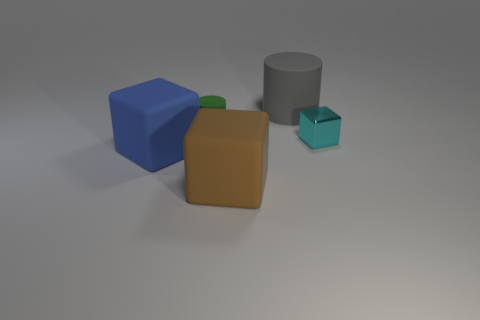What number of things are both left of the cyan shiny thing and in front of the green matte cylinder?
Make the answer very short. 2. What material is the cylinder to the left of the big gray rubber thing?
Offer a terse response. Rubber. There is a blue object that is made of the same material as the large cylinder; what size is it?
Ensure brevity in your answer.  Large. There is a object in front of the large blue matte thing; is its size the same as the object that is behind the green rubber object?
Your response must be concise. Yes. What material is the cylinder that is the same size as the metal object?
Provide a succinct answer. Rubber. What is the big object that is in front of the tiny rubber cylinder and to the right of the big blue block made of?
Offer a terse response. Rubber. Are there any big gray rubber things?
Your response must be concise. Yes. There is a tiny rubber cylinder; is its color the same as the large block in front of the blue cube?
Provide a succinct answer. No. Is there anything else that is the same shape as the green object?
Give a very brief answer. Yes. The large matte object behind the cylinder that is in front of the large object that is behind the cyan shiny cube is what shape?
Ensure brevity in your answer.  Cylinder. 